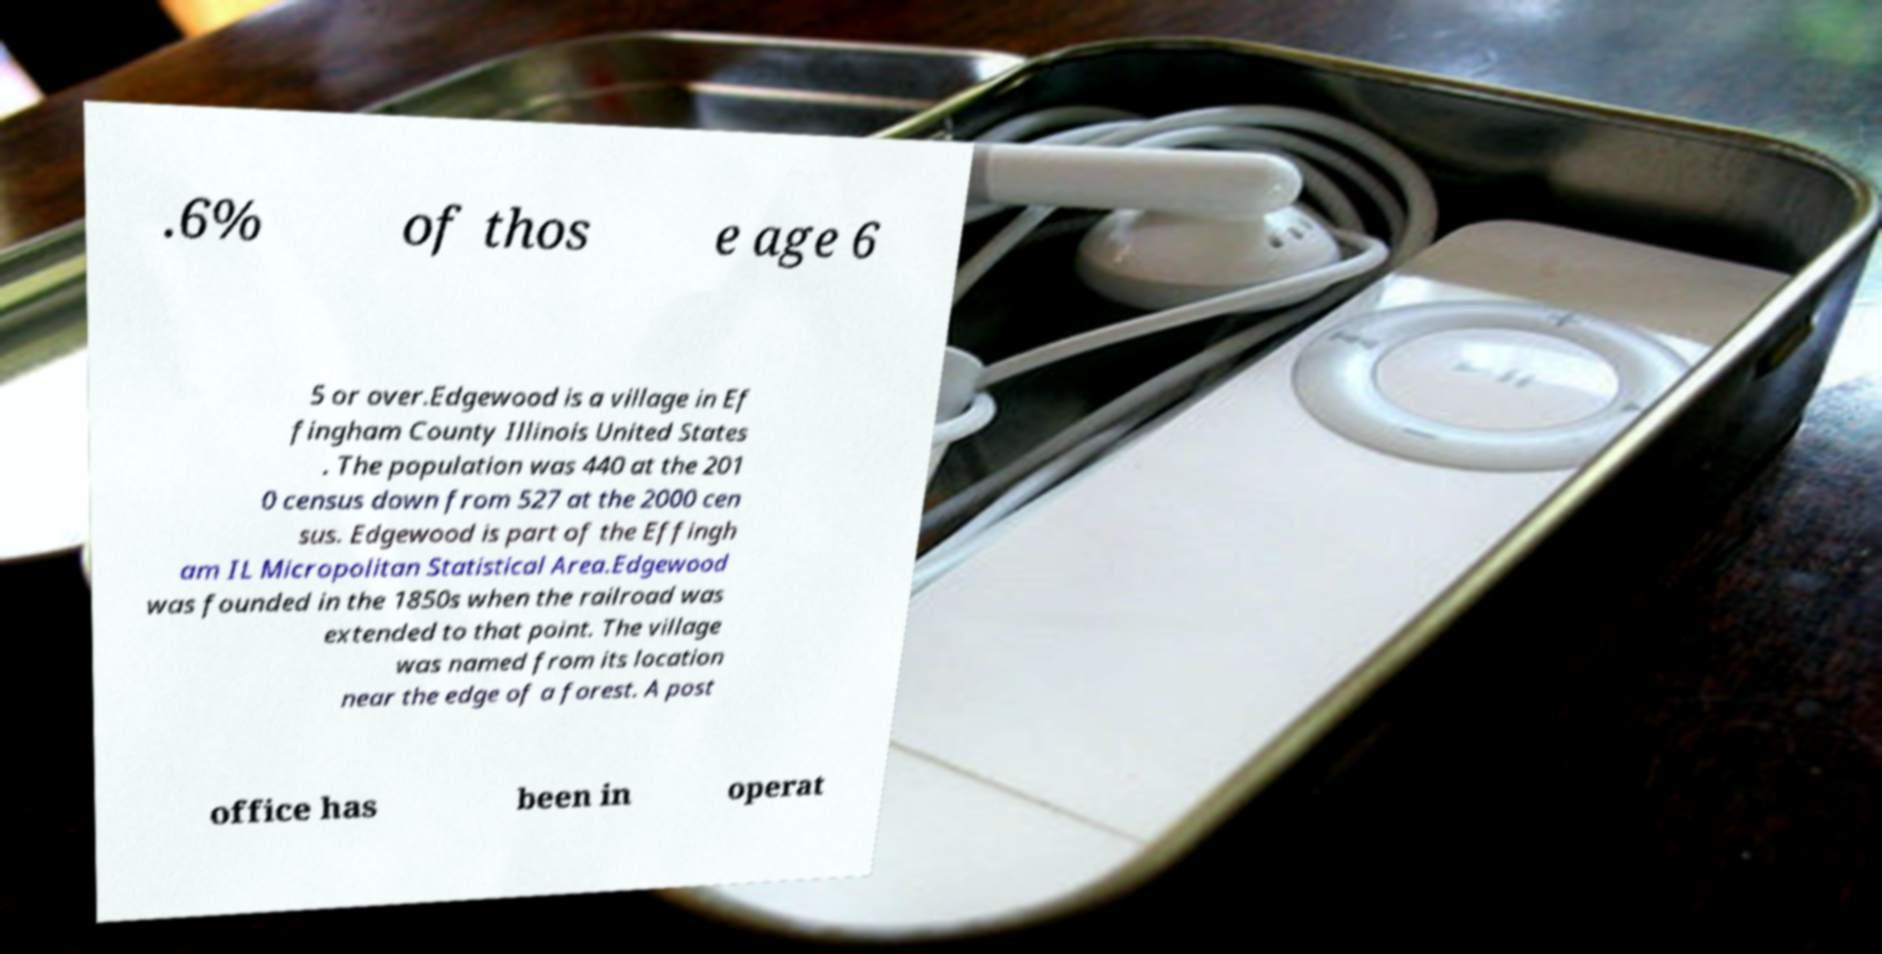Can you read and provide the text displayed in the image?This photo seems to have some interesting text. Can you extract and type it out for me? .6% of thos e age 6 5 or over.Edgewood is a village in Ef fingham County Illinois United States . The population was 440 at the 201 0 census down from 527 at the 2000 cen sus. Edgewood is part of the Effingh am IL Micropolitan Statistical Area.Edgewood was founded in the 1850s when the railroad was extended to that point. The village was named from its location near the edge of a forest. A post office has been in operat 